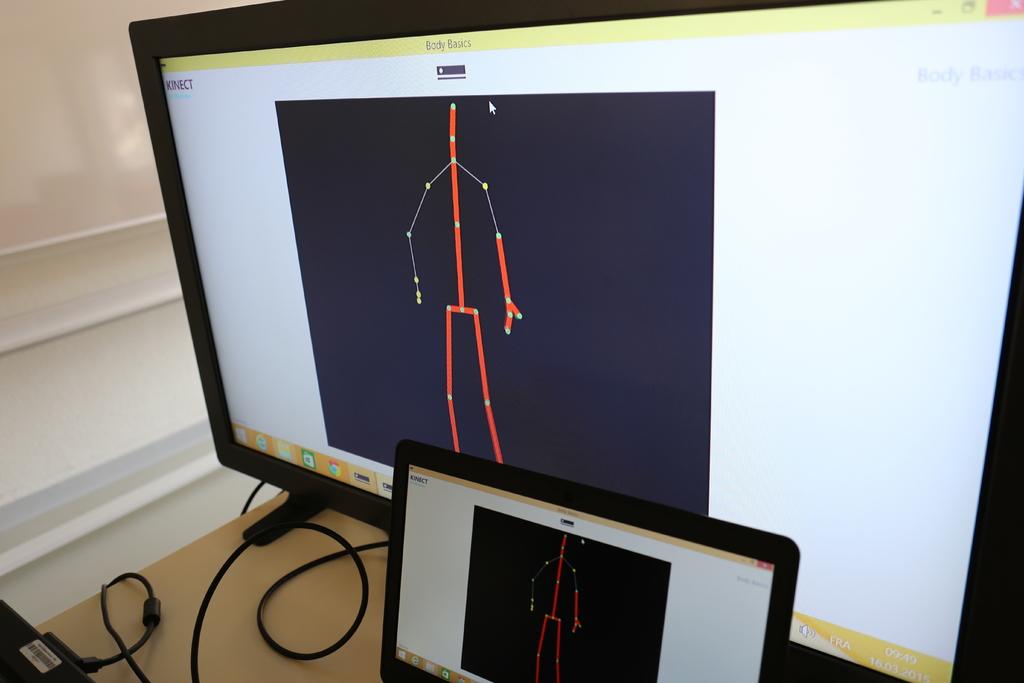What is in the title bar of this application?
Keep it short and to the point. Body basics. 